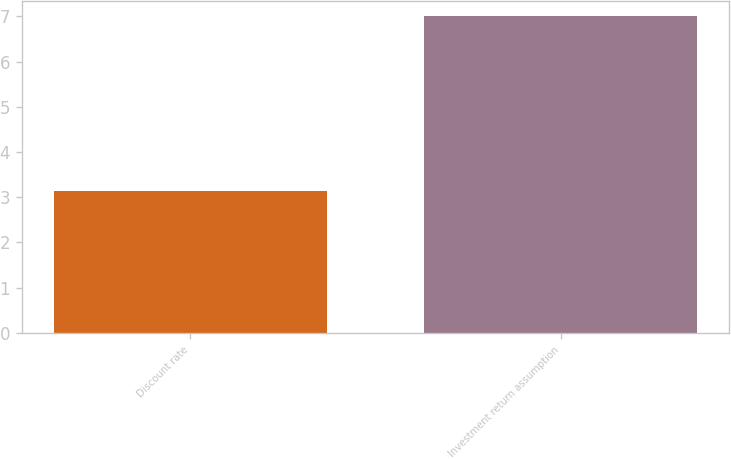Convert chart. <chart><loc_0><loc_0><loc_500><loc_500><bar_chart><fcel>Discount rate<fcel>Investment return assumption<nl><fcel>3.14<fcel>7<nl></chart> 